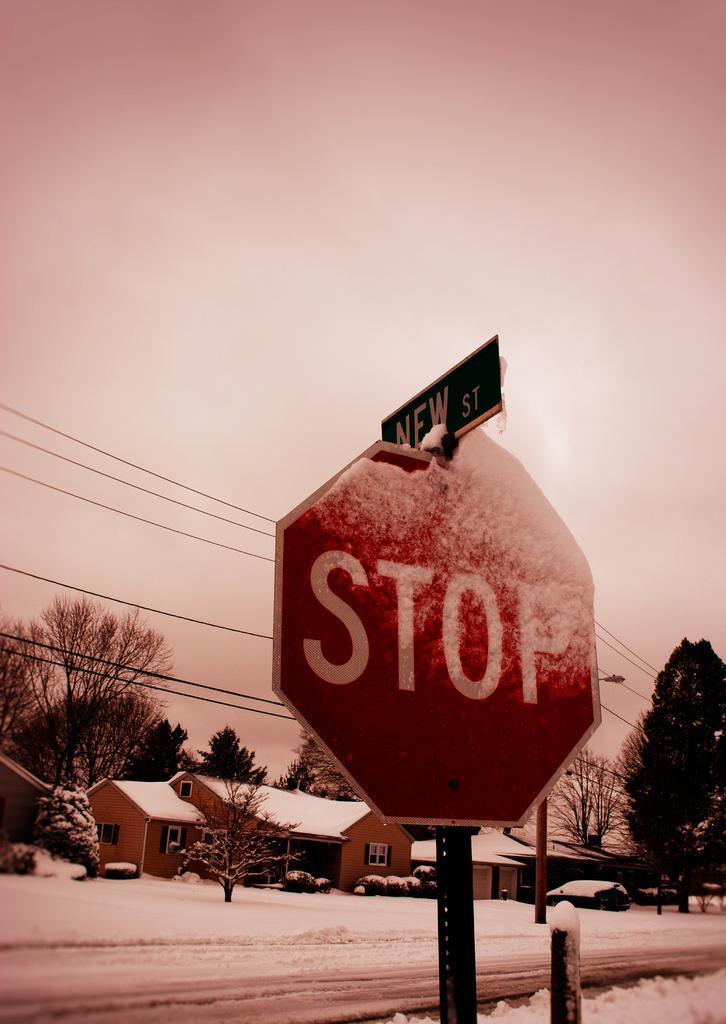What street is this?
Provide a short and direct response. New. 